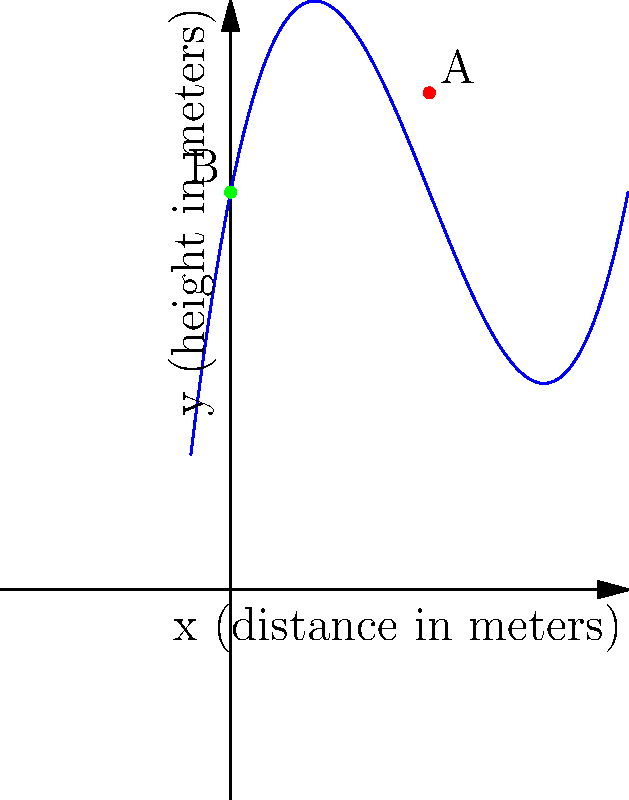As a train enthusiast, you're studying the trajectory of a train's whistle sound wave. The path of the sound wave can be modeled by the polynomial function $f(x) = 0.1x^3 - 1.5x^2 + 5x + 10$, where $x$ is the horizontal distance in meters and $f(x)$ is the height in meters. Point A represents the position of the train when it blows the whistle, and point B is where an observer is standing. What is the horizontal distance between the train and the observer when the whistle is blown? To solve this problem, we need to follow these steps:

1) First, we need to identify the coordinates of points A and B from the graph:
   Point A (train position): (5, 12.5)
   Point B (observer position): (0, 10)

2) The horizontal distance between the train and the observer is the difference between their x-coordinates:

   Distance = x-coordinate of A - x-coordinate of B
             = 5 - 0
             = 5 meters

3) We can verify this by plugging x = 5 into the given function:

   $f(5) = 0.1(5^3) - 1.5(5^2) + 5(5) + 10$
         $= 0.1(125) - 1.5(25) + 25 + 10$
         $= 12.5 - 37.5 + 25 + 10$
         $= 12.5$

   This matches the y-coordinate of point A in the graph.

Therefore, the horizontal distance between the train and the observer when the whistle is blown is 5 meters.
Answer: 5 meters 